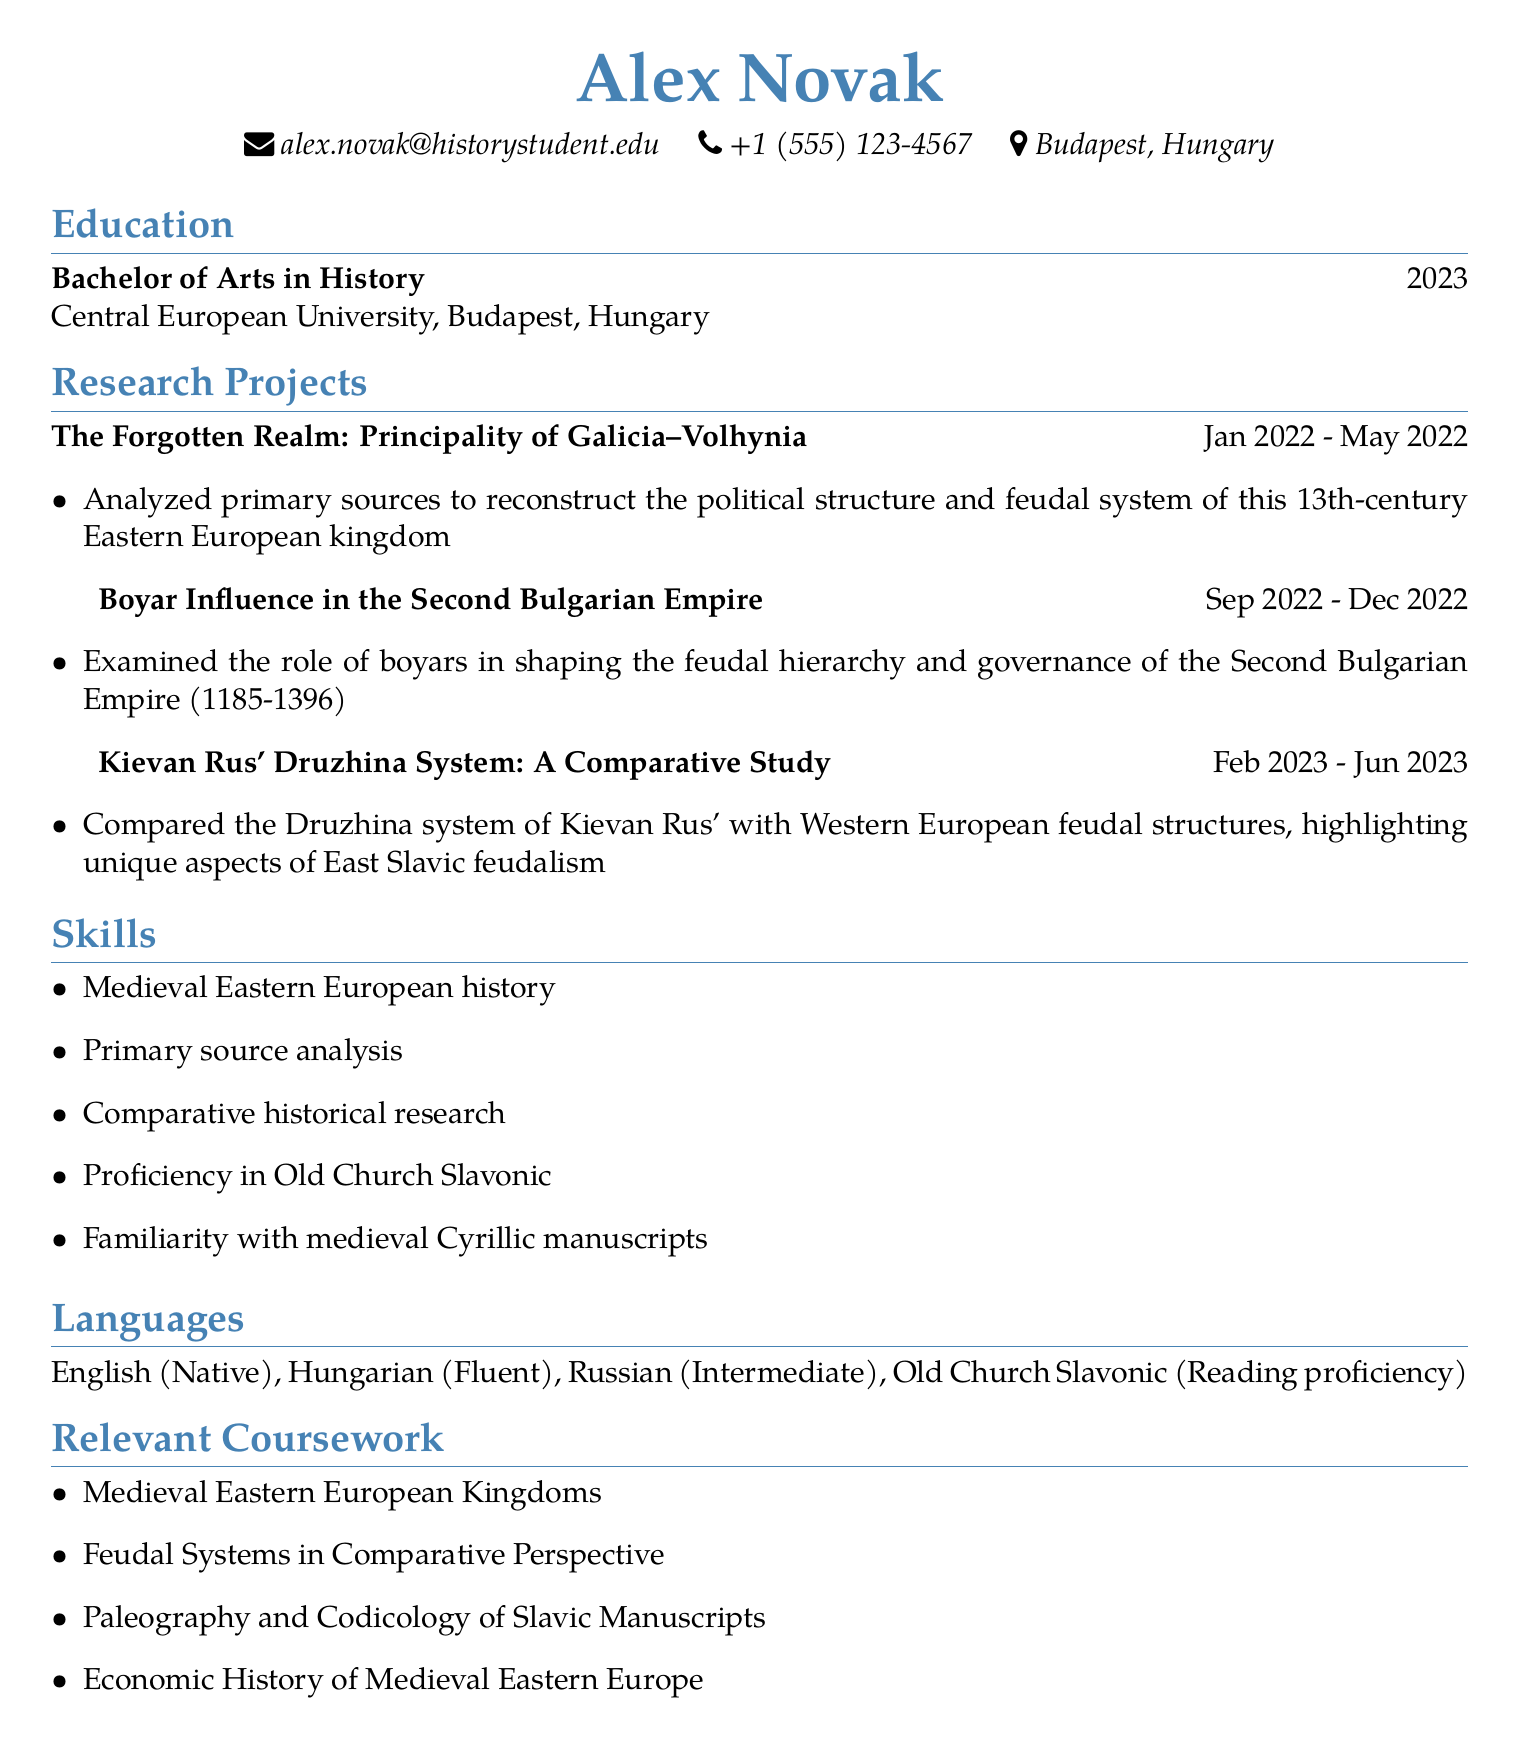What is the name of the person? The name of the person is displayed at the top of the document.
Answer: Alex Novak What degree did Alex Novak graduate with? The degree information is provided in the education section of the document.
Answer: Bachelor of Arts in History When did the research project on Galicia–Volhynia take place? The duration of the project is clearly stated next to its title in the document.
Answer: Jan 2022 - May 2022 How many languages can Alex speak? The languages section specifies the number of languages mentioned in the document.
Answer: Four Which research project examines boyars? The title of the project concerning boyars is noted in the research projects section.
Answer: Boyar Influence in the Second Bulgarian Empire What unique aspect does the project on Kievan Rus' emphasize? The project description includes a focus that distinguishes it from Western European feudalism.
Answer: Unique aspects of East Slavic feudalism Which skill is related to manuscript reading? The skills section lists competencies related to manuscript reading.
Answer: Familiarity with medieval Cyrillic manuscripts What university did Alex Novak attend? The university is listed in the education section of the document.
Answer: Central European University What was the duration of the Kievan Rus' research project? The project duration is provided next to its title in the document.
Answer: Feb 2023 - Jun 2023 